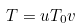Convert formula to latex. <formula><loc_0><loc_0><loc_500><loc_500>T = u T _ { 0 } v</formula> 